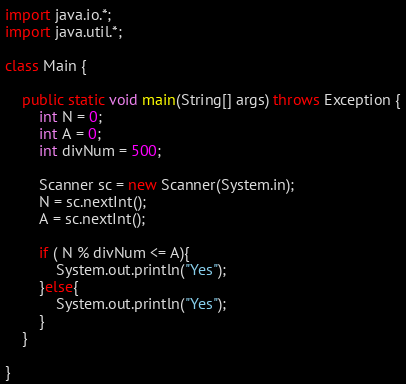<code> <loc_0><loc_0><loc_500><loc_500><_Java_>import java.io.*;
import java.util.*;

class Main {
    
    public static void main(String[] args) throws Exception {
        int N = 0;
        int A = 0;
        int divNum = 500;

        Scanner sc = new Scanner(System.in);
        N = sc.nextInt();
        A = sc.nextInt();

        if ( N % divNum <= A){
            System.out.println("Yes");
        }else{
            System.out.println("Yes");
        }            
    }

}
</code> 